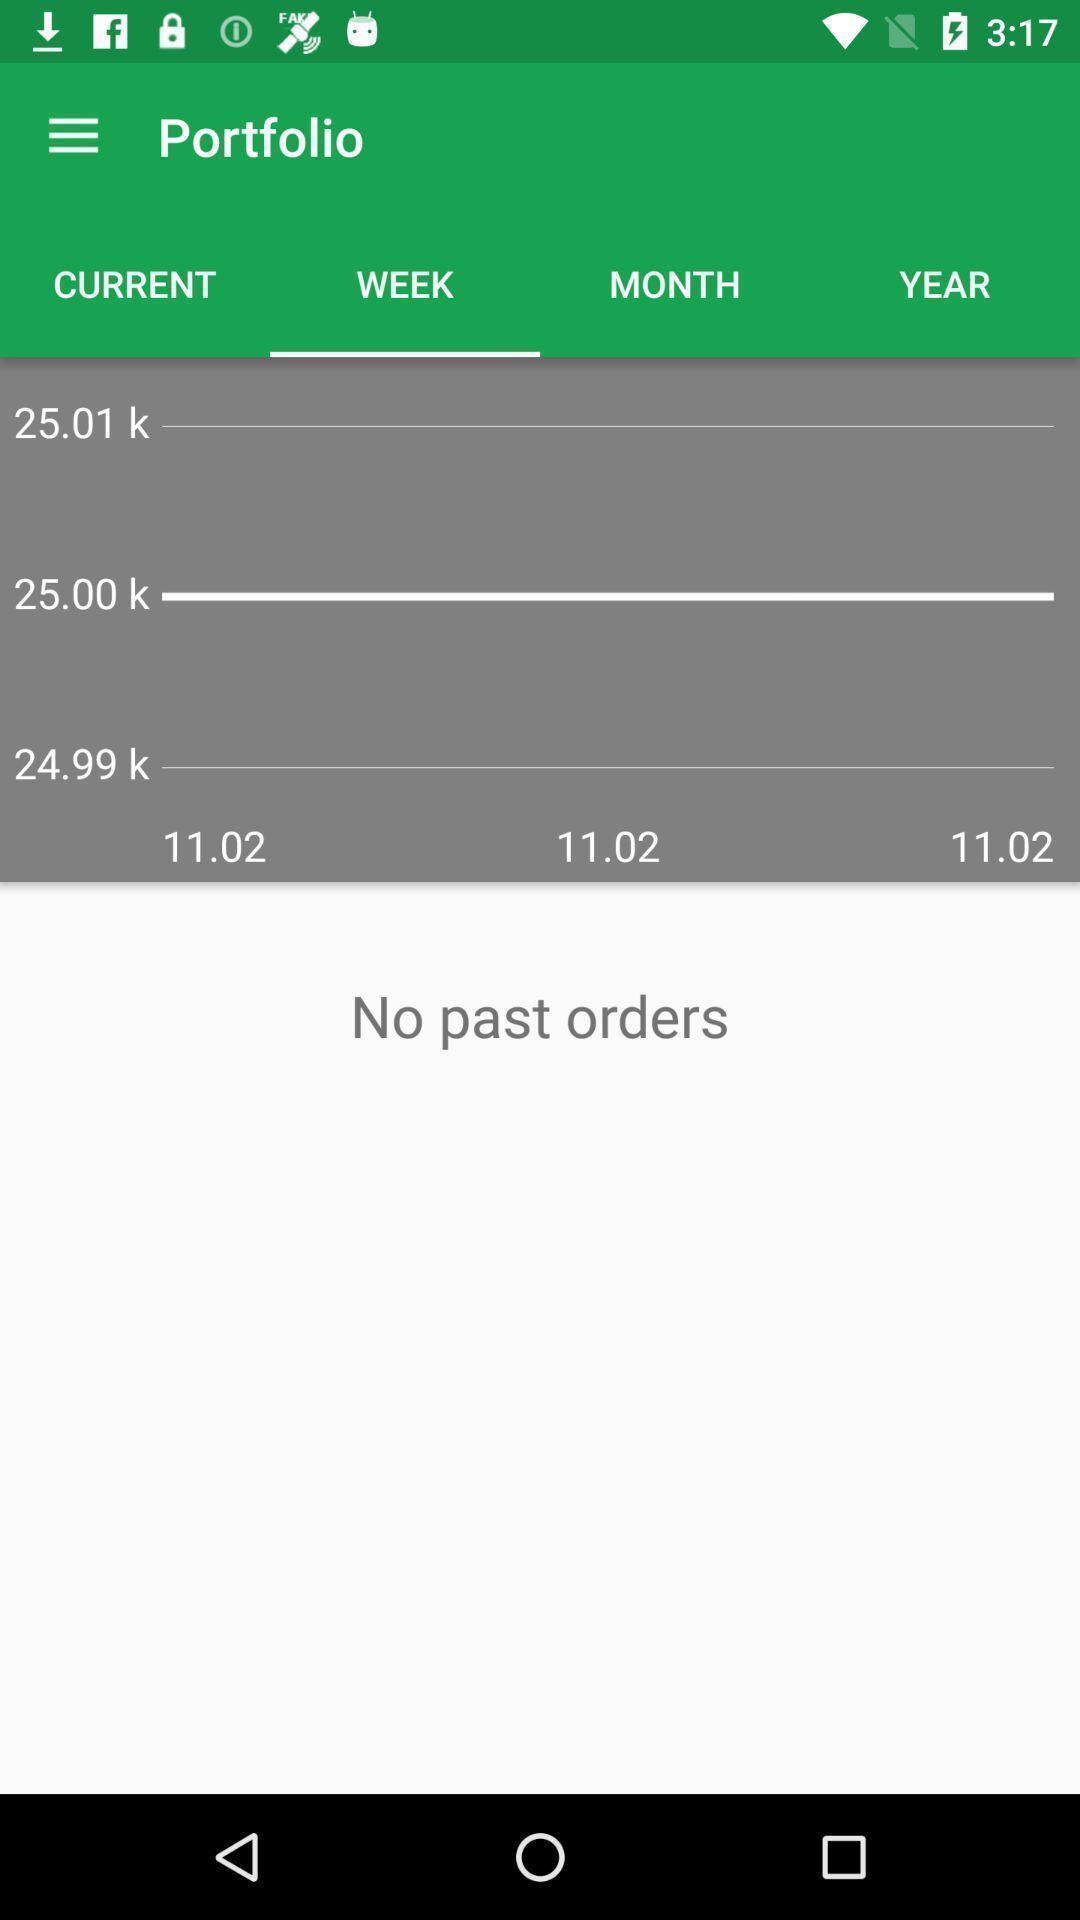Provide a detailed account of this screenshot. Screen shows no past orders in port folio. 